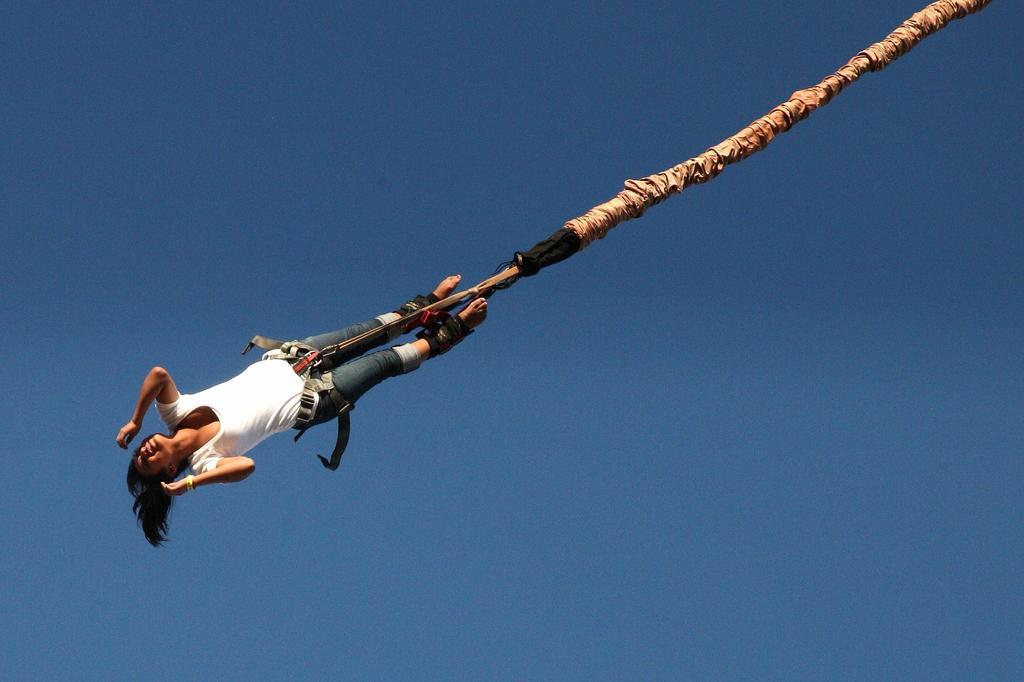Please provide a concise description of this image. This image consists of a woman wearing a white T-shirt. She is tied to a rope. It looks like a skydiving. In the background, we can see the sky. 